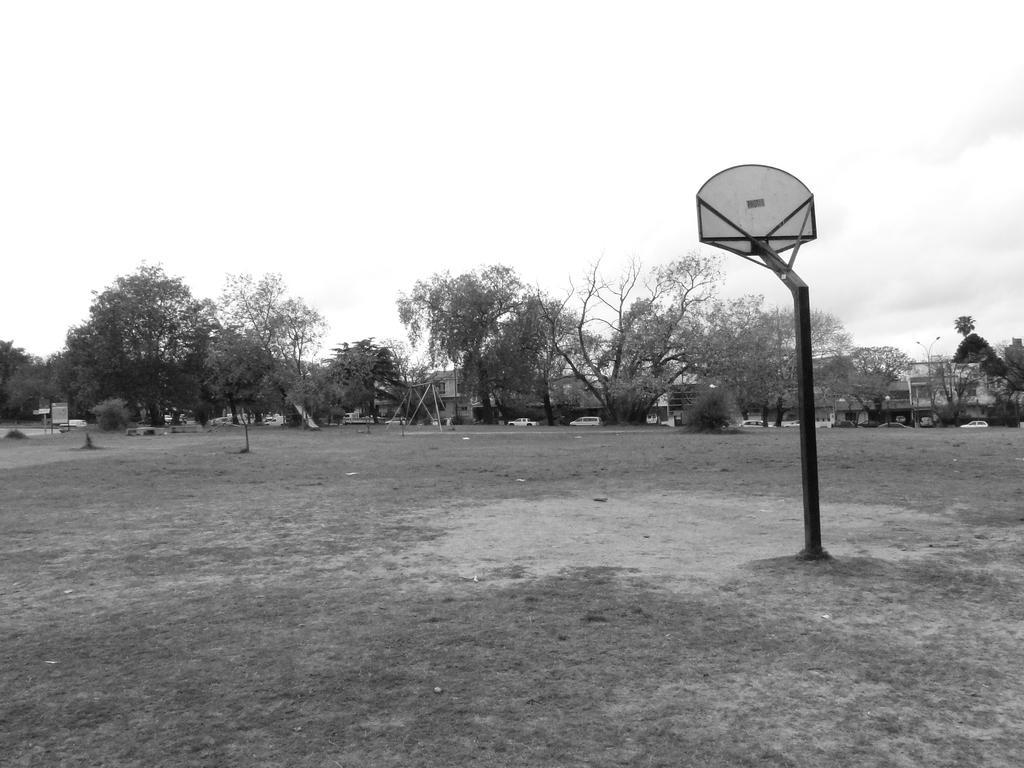How would you summarize this image in a sentence or two? This is a black and white image. On the right side of the image we can see pole on the right side. In the background we can see trees, grass, cars, buildings and sky. 